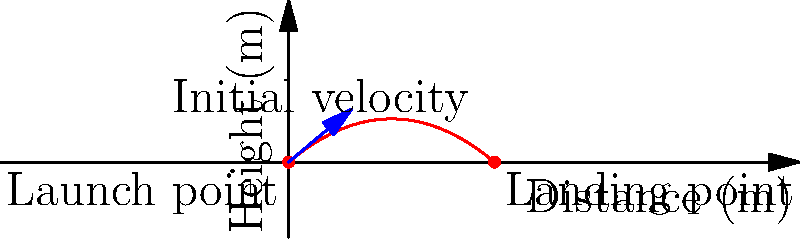During a thrilling London Spirit match at Lord's, a cricket ball is hit with an initial velocity of 25 m/s at an angle of 40° above the horizontal. Assuming air resistance is negligible, calculate the maximum height reached by the ball and the total horizontal distance it travels before landing. Use g = 9.8 m/s². Let's approach this step-by-step:

1) First, we need to break down the initial velocity into its horizontal and vertical components:
   $v_{0x} = v_0 \cos \theta = 25 \cos 40° = 19.15$ m/s
   $v_{0y} = v_0 \sin \theta = 25 \sin 40° = 16.07$ m/s

2) To find the maximum height, we use the equation:
   $h_{max} = \frac{v_{0y}^2}{2g}$
   $h_{max} = \frac{(16.07)^2}{2(9.8)} = 13.17$ m

3) To find the total horizontal distance (range), we need the time of flight. The ball lands when its height is zero:
   $0 = v_{0y}t - \frac{1}{2}gt^2$
   Solving this quadratic equation:
   $t = \frac{2v_{0y}}{g} = \frac{2(16.07)}{9.8} = 3.28$ s

4) Now we can calculate the range:
   $R = v_{0x}t = 19.15 \times 3.28 = 62.81$ m

Therefore, the maximum height reached is 13.17 m, and the total horizontal distance traveled is 62.81 m.
Answer: Maximum height: 13.17 m; Horizontal distance: 62.81 m 